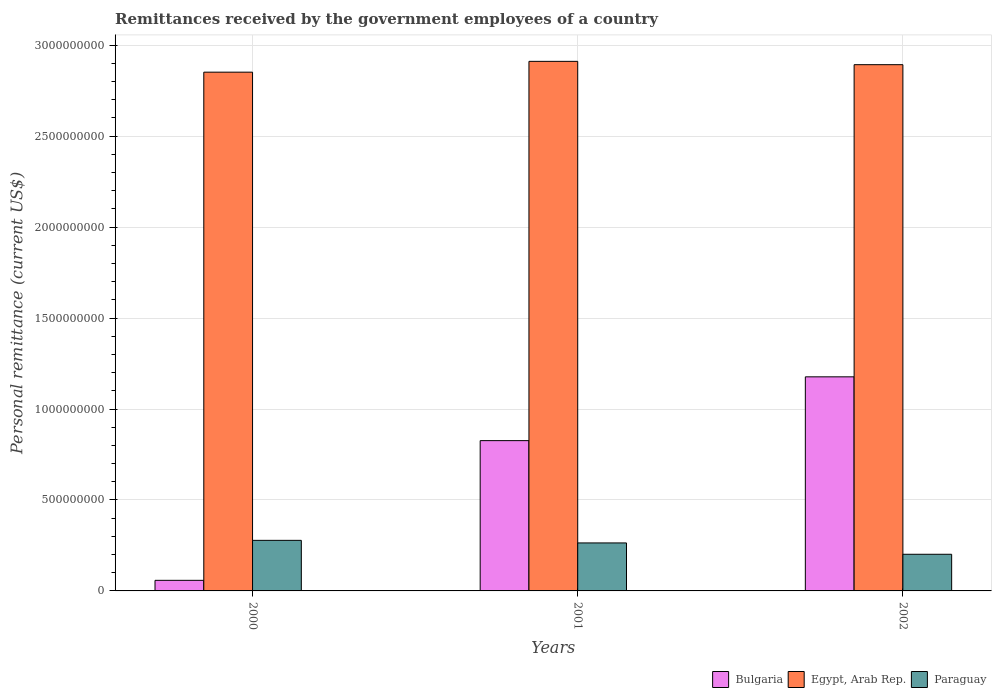How many groups of bars are there?
Your answer should be very brief. 3. Are the number of bars on each tick of the X-axis equal?
Offer a very short reply. Yes. How many bars are there on the 1st tick from the left?
Your response must be concise. 3. How many bars are there on the 2nd tick from the right?
Ensure brevity in your answer.  3. What is the label of the 2nd group of bars from the left?
Your answer should be very brief. 2001. What is the remittances received by the government employees in Egypt, Arab Rep. in 2001?
Provide a short and direct response. 2.91e+09. Across all years, what is the maximum remittances received by the government employees in Egypt, Arab Rep.?
Provide a succinct answer. 2.91e+09. Across all years, what is the minimum remittances received by the government employees in Egypt, Arab Rep.?
Give a very brief answer. 2.85e+09. In which year was the remittances received by the government employees in Bulgaria minimum?
Ensure brevity in your answer.  2000. What is the total remittances received by the government employees in Egypt, Arab Rep. in the graph?
Your answer should be very brief. 8.66e+09. What is the difference between the remittances received by the government employees in Paraguay in 2000 and that in 2002?
Your answer should be compact. 7.65e+07. What is the difference between the remittances received by the government employees in Paraguay in 2000 and the remittances received by the government employees in Egypt, Arab Rep. in 2002?
Provide a succinct answer. -2.62e+09. What is the average remittances received by the government employees in Bulgaria per year?
Your response must be concise. 6.87e+08. In the year 2000, what is the difference between the remittances received by the government employees in Bulgaria and remittances received by the government employees in Egypt, Arab Rep.?
Ensure brevity in your answer.  -2.79e+09. What is the ratio of the remittances received by the government employees in Bulgaria in 2000 to that in 2002?
Provide a short and direct response. 0.05. What is the difference between the highest and the second highest remittances received by the government employees in Bulgaria?
Your response must be concise. 3.51e+08. What is the difference between the highest and the lowest remittances received by the government employees in Bulgaria?
Make the answer very short. 1.12e+09. In how many years, is the remittances received by the government employees in Egypt, Arab Rep. greater than the average remittances received by the government employees in Egypt, Arab Rep. taken over all years?
Ensure brevity in your answer.  2. What does the 2nd bar from the left in 2001 represents?
Offer a very short reply. Egypt, Arab Rep. What does the 1st bar from the right in 2000 represents?
Your answer should be compact. Paraguay. How many bars are there?
Make the answer very short. 9. How many years are there in the graph?
Give a very brief answer. 3. What is the difference between two consecutive major ticks on the Y-axis?
Your answer should be very brief. 5.00e+08. Are the values on the major ticks of Y-axis written in scientific E-notation?
Keep it short and to the point. No. Does the graph contain grids?
Your response must be concise. Yes. Where does the legend appear in the graph?
Your answer should be compact. Bottom right. How many legend labels are there?
Your answer should be very brief. 3. How are the legend labels stacked?
Provide a succinct answer. Horizontal. What is the title of the graph?
Provide a succinct answer. Remittances received by the government employees of a country. Does "High income" appear as one of the legend labels in the graph?
Ensure brevity in your answer.  No. What is the label or title of the Y-axis?
Keep it short and to the point. Personal remittance (current US$). What is the Personal remittance (current US$) in Bulgaria in 2000?
Your response must be concise. 5.82e+07. What is the Personal remittance (current US$) in Egypt, Arab Rep. in 2000?
Make the answer very short. 2.85e+09. What is the Personal remittance (current US$) in Paraguay in 2000?
Provide a succinct answer. 2.78e+08. What is the Personal remittance (current US$) of Bulgaria in 2001?
Offer a terse response. 8.26e+08. What is the Personal remittance (current US$) of Egypt, Arab Rep. in 2001?
Offer a very short reply. 2.91e+09. What is the Personal remittance (current US$) in Paraguay in 2001?
Provide a succinct answer. 2.64e+08. What is the Personal remittance (current US$) of Bulgaria in 2002?
Provide a succinct answer. 1.18e+09. What is the Personal remittance (current US$) in Egypt, Arab Rep. in 2002?
Your response must be concise. 2.89e+09. What is the Personal remittance (current US$) in Paraguay in 2002?
Your answer should be compact. 2.02e+08. Across all years, what is the maximum Personal remittance (current US$) in Bulgaria?
Give a very brief answer. 1.18e+09. Across all years, what is the maximum Personal remittance (current US$) of Egypt, Arab Rep.?
Your answer should be very brief. 2.91e+09. Across all years, what is the maximum Personal remittance (current US$) of Paraguay?
Your answer should be very brief. 2.78e+08. Across all years, what is the minimum Personal remittance (current US$) of Bulgaria?
Offer a very short reply. 5.82e+07. Across all years, what is the minimum Personal remittance (current US$) in Egypt, Arab Rep.?
Offer a terse response. 2.85e+09. Across all years, what is the minimum Personal remittance (current US$) in Paraguay?
Offer a very short reply. 2.02e+08. What is the total Personal remittance (current US$) of Bulgaria in the graph?
Provide a succinct answer. 2.06e+09. What is the total Personal remittance (current US$) in Egypt, Arab Rep. in the graph?
Offer a terse response. 8.66e+09. What is the total Personal remittance (current US$) of Paraguay in the graph?
Give a very brief answer. 7.43e+08. What is the difference between the Personal remittance (current US$) in Bulgaria in 2000 and that in 2001?
Provide a succinct answer. -7.68e+08. What is the difference between the Personal remittance (current US$) in Egypt, Arab Rep. in 2000 and that in 2001?
Keep it short and to the point. -5.94e+07. What is the difference between the Personal remittance (current US$) of Paraguay in 2000 and that in 2001?
Provide a succinct answer. 1.42e+07. What is the difference between the Personal remittance (current US$) of Bulgaria in 2000 and that in 2002?
Offer a terse response. -1.12e+09. What is the difference between the Personal remittance (current US$) in Egypt, Arab Rep. in 2000 and that in 2002?
Give a very brief answer. -4.11e+07. What is the difference between the Personal remittance (current US$) in Paraguay in 2000 and that in 2002?
Your answer should be very brief. 7.65e+07. What is the difference between the Personal remittance (current US$) of Bulgaria in 2001 and that in 2002?
Give a very brief answer. -3.51e+08. What is the difference between the Personal remittance (current US$) in Egypt, Arab Rep. in 2001 and that in 2002?
Keep it short and to the point. 1.83e+07. What is the difference between the Personal remittance (current US$) of Paraguay in 2001 and that in 2002?
Keep it short and to the point. 6.23e+07. What is the difference between the Personal remittance (current US$) in Bulgaria in 2000 and the Personal remittance (current US$) in Egypt, Arab Rep. in 2001?
Provide a short and direct response. -2.85e+09. What is the difference between the Personal remittance (current US$) in Bulgaria in 2000 and the Personal remittance (current US$) in Paraguay in 2001?
Your answer should be compact. -2.06e+08. What is the difference between the Personal remittance (current US$) of Egypt, Arab Rep. in 2000 and the Personal remittance (current US$) of Paraguay in 2001?
Provide a short and direct response. 2.59e+09. What is the difference between the Personal remittance (current US$) in Bulgaria in 2000 and the Personal remittance (current US$) in Egypt, Arab Rep. in 2002?
Provide a short and direct response. -2.83e+09. What is the difference between the Personal remittance (current US$) in Bulgaria in 2000 and the Personal remittance (current US$) in Paraguay in 2002?
Keep it short and to the point. -1.43e+08. What is the difference between the Personal remittance (current US$) of Egypt, Arab Rep. in 2000 and the Personal remittance (current US$) of Paraguay in 2002?
Your answer should be very brief. 2.65e+09. What is the difference between the Personal remittance (current US$) of Bulgaria in 2001 and the Personal remittance (current US$) of Egypt, Arab Rep. in 2002?
Provide a succinct answer. -2.07e+09. What is the difference between the Personal remittance (current US$) in Bulgaria in 2001 and the Personal remittance (current US$) in Paraguay in 2002?
Your answer should be compact. 6.25e+08. What is the difference between the Personal remittance (current US$) in Egypt, Arab Rep. in 2001 and the Personal remittance (current US$) in Paraguay in 2002?
Provide a short and direct response. 2.71e+09. What is the average Personal remittance (current US$) in Bulgaria per year?
Your response must be concise. 6.87e+08. What is the average Personal remittance (current US$) in Egypt, Arab Rep. per year?
Keep it short and to the point. 2.89e+09. What is the average Personal remittance (current US$) in Paraguay per year?
Offer a terse response. 2.48e+08. In the year 2000, what is the difference between the Personal remittance (current US$) in Bulgaria and Personal remittance (current US$) in Egypt, Arab Rep.?
Offer a very short reply. -2.79e+09. In the year 2000, what is the difference between the Personal remittance (current US$) of Bulgaria and Personal remittance (current US$) of Paraguay?
Your answer should be very brief. -2.20e+08. In the year 2000, what is the difference between the Personal remittance (current US$) of Egypt, Arab Rep. and Personal remittance (current US$) of Paraguay?
Keep it short and to the point. 2.57e+09. In the year 2001, what is the difference between the Personal remittance (current US$) of Bulgaria and Personal remittance (current US$) of Egypt, Arab Rep.?
Make the answer very short. -2.09e+09. In the year 2001, what is the difference between the Personal remittance (current US$) in Bulgaria and Personal remittance (current US$) in Paraguay?
Keep it short and to the point. 5.62e+08. In the year 2001, what is the difference between the Personal remittance (current US$) in Egypt, Arab Rep. and Personal remittance (current US$) in Paraguay?
Your response must be concise. 2.65e+09. In the year 2002, what is the difference between the Personal remittance (current US$) in Bulgaria and Personal remittance (current US$) in Egypt, Arab Rep.?
Provide a succinct answer. -1.72e+09. In the year 2002, what is the difference between the Personal remittance (current US$) of Bulgaria and Personal remittance (current US$) of Paraguay?
Keep it short and to the point. 9.75e+08. In the year 2002, what is the difference between the Personal remittance (current US$) in Egypt, Arab Rep. and Personal remittance (current US$) in Paraguay?
Keep it short and to the point. 2.69e+09. What is the ratio of the Personal remittance (current US$) of Bulgaria in 2000 to that in 2001?
Make the answer very short. 0.07. What is the ratio of the Personal remittance (current US$) of Egypt, Arab Rep. in 2000 to that in 2001?
Provide a succinct answer. 0.98. What is the ratio of the Personal remittance (current US$) in Paraguay in 2000 to that in 2001?
Provide a succinct answer. 1.05. What is the ratio of the Personal remittance (current US$) in Bulgaria in 2000 to that in 2002?
Provide a short and direct response. 0.05. What is the ratio of the Personal remittance (current US$) in Egypt, Arab Rep. in 2000 to that in 2002?
Your response must be concise. 0.99. What is the ratio of the Personal remittance (current US$) of Paraguay in 2000 to that in 2002?
Give a very brief answer. 1.38. What is the ratio of the Personal remittance (current US$) of Bulgaria in 2001 to that in 2002?
Your answer should be compact. 0.7. What is the ratio of the Personal remittance (current US$) of Paraguay in 2001 to that in 2002?
Offer a very short reply. 1.31. What is the difference between the highest and the second highest Personal remittance (current US$) in Bulgaria?
Provide a short and direct response. 3.51e+08. What is the difference between the highest and the second highest Personal remittance (current US$) of Egypt, Arab Rep.?
Make the answer very short. 1.83e+07. What is the difference between the highest and the second highest Personal remittance (current US$) of Paraguay?
Offer a very short reply. 1.42e+07. What is the difference between the highest and the lowest Personal remittance (current US$) in Bulgaria?
Offer a terse response. 1.12e+09. What is the difference between the highest and the lowest Personal remittance (current US$) in Egypt, Arab Rep.?
Offer a very short reply. 5.94e+07. What is the difference between the highest and the lowest Personal remittance (current US$) in Paraguay?
Ensure brevity in your answer.  7.65e+07. 